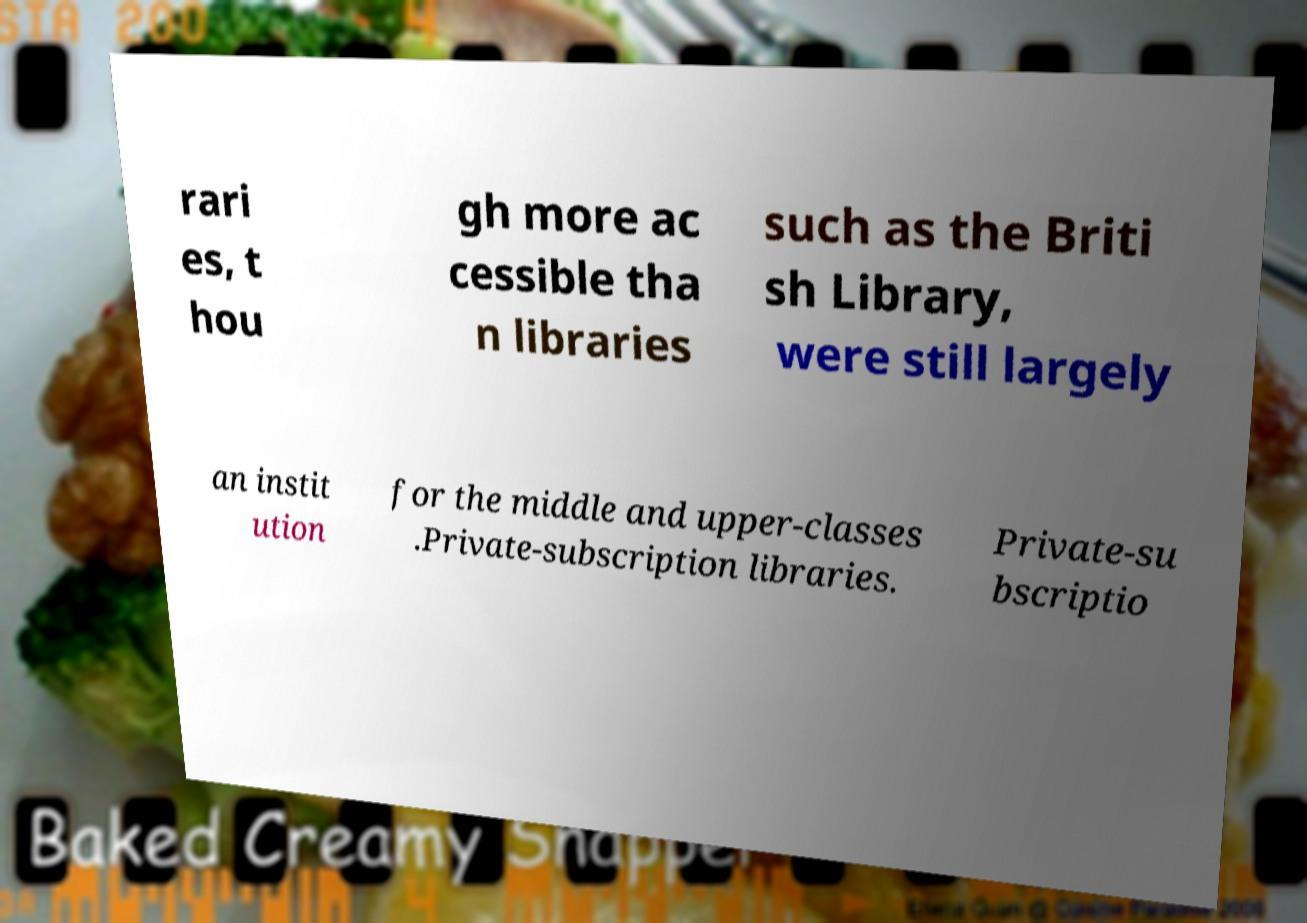Can you accurately transcribe the text from the provided image for me? rari es, t hou gh more ac cessible tha n libraries such as the Briti sh Library, were still largely an instit ution for the middle and upper-classes .Private-subscription libraries. Private-su bscriptio 